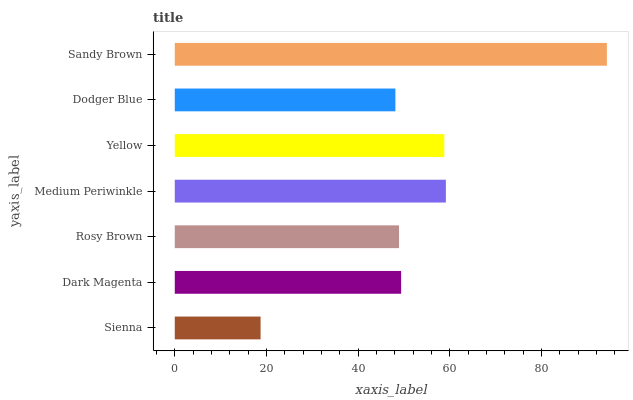Is Sienna the minimum?
Answer yes or no. Yes. Is Sandy Brown the maximum?
Answer yes or no. Yes. Is Dark Magenta the minimum?
Answer yes or no. No. Is Dark Magenta the maximum?
Answer yes or no. No. Is Dark Magenta greater than Sienna?
Answer yes or no. Yes. Is Sienna less than Dark Magenta?
Answer yes or no. Yes. Is Sienna greater than Dark Magenta?
Answer yes or no. No. Is Dark Magenta less than Sienna?
Answer yes or no. No. Is Dark Magenta the high median?
Answer yes or no. Yes. Is Dark Magenta the low median?
Answer yes or no. Yes. Is Yellow the high median?
Answer yes or no. No. Is Sienna the low median?
Answer yes or no. No. 